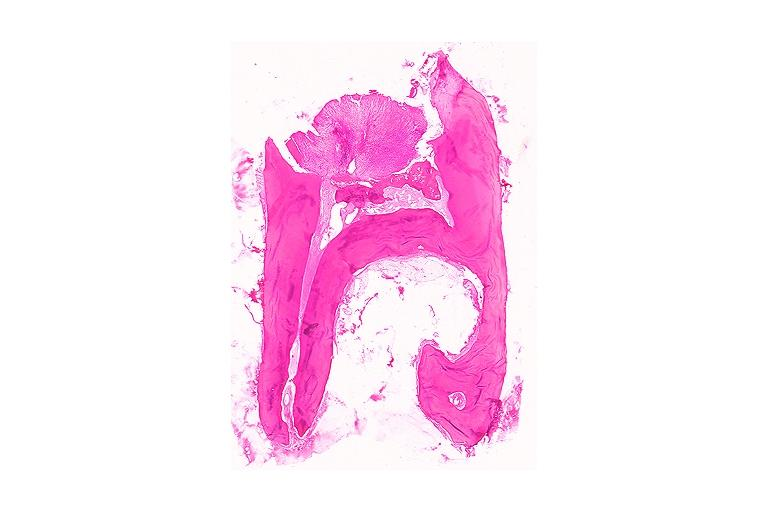where is this?
Answer the question using a single word or phrase. Oral 